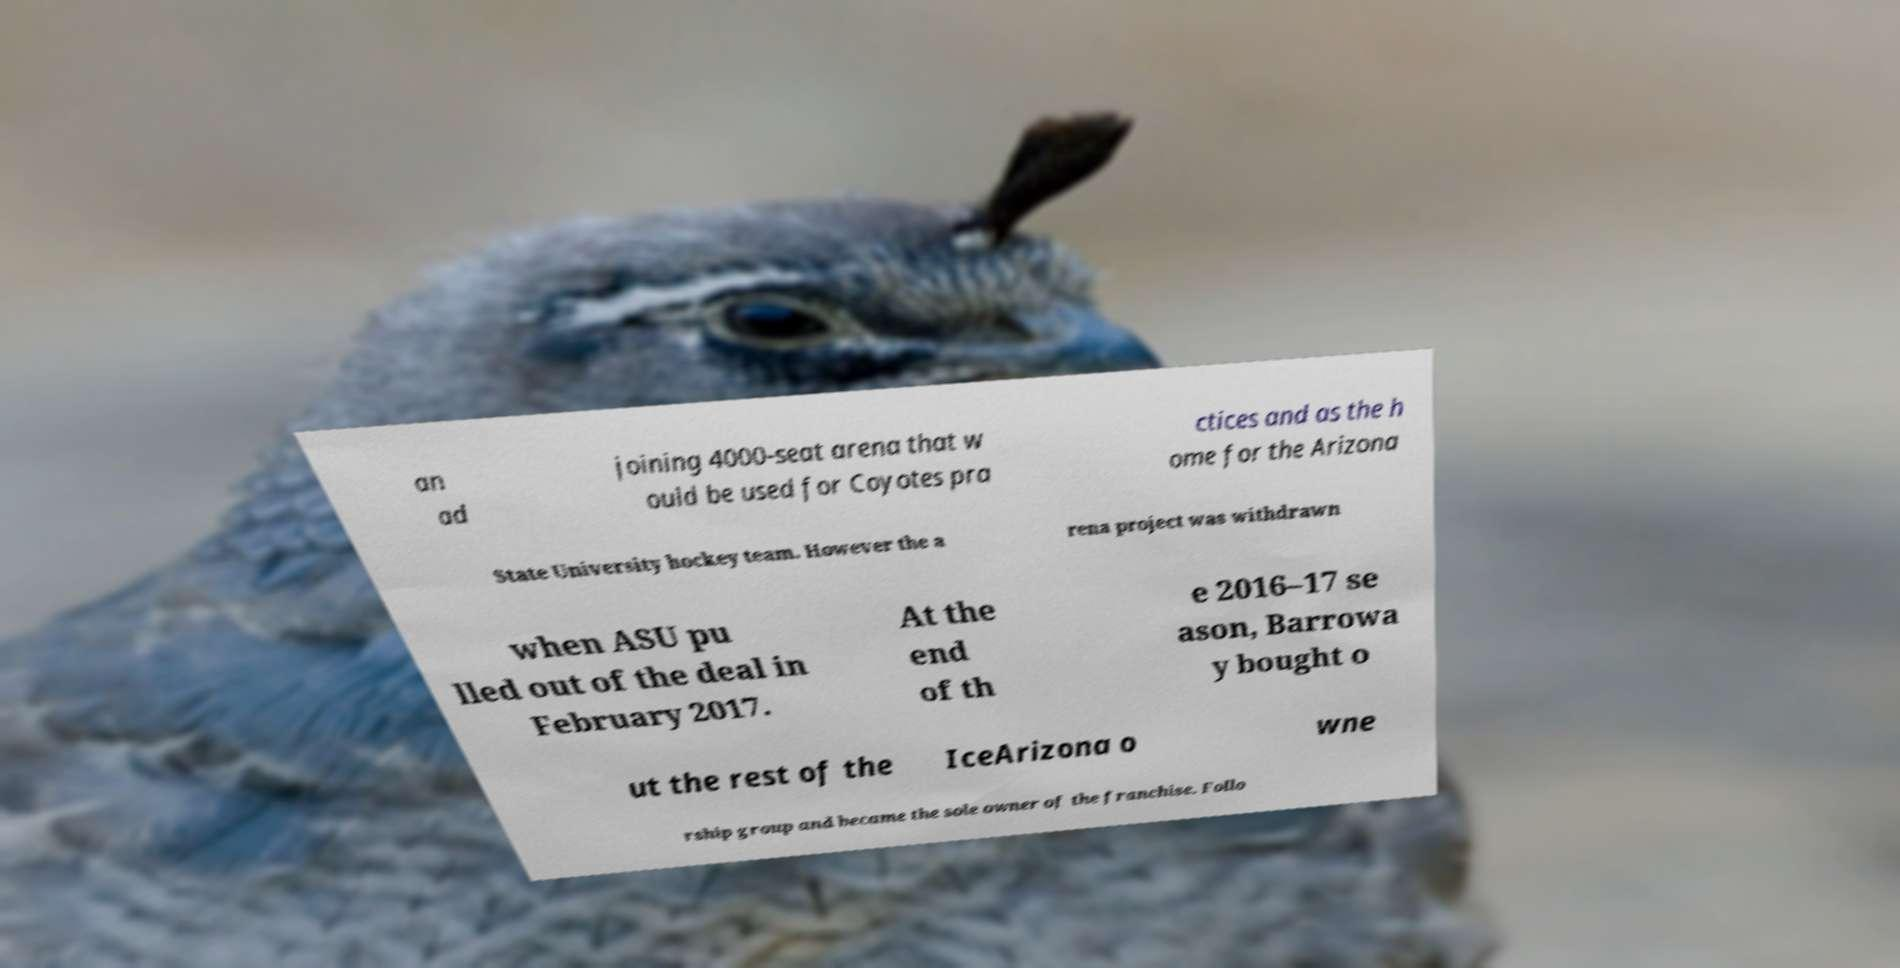Please identify and transcribe the text found in this image. an ad joining 4000-seat arena that w ould be used for Coyotes pra ctices and as the h ome for the Arizona State University hockey team. However the a rena project was withdrawn when ASU pu lled out of the deal in February 2017. At the end of th e 2016–17 se ason, Barrowa y bought o ut the rest of the IceArizona o wne rship group and became the sole owner of the franchise. Follo 